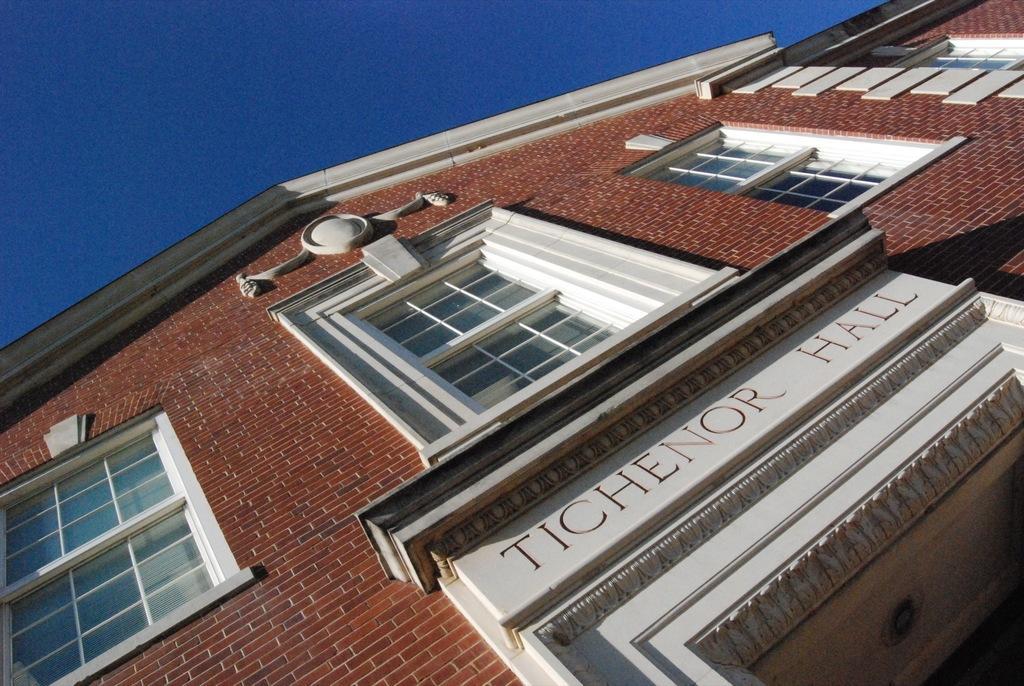Can you describe this image briefly? In this picture I can see there is a building and it has a name plate and the sky is clear. 